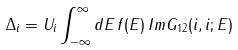<formula> <loc_0><loc_0><loc_500><loc_500>\Delta _ { i } = U _ { i } \int _ { - \infty } ^ { \infty } d E \, f ( E ) \, I m { G } _ { 1 2 } ( i , i ; E )</formula> 